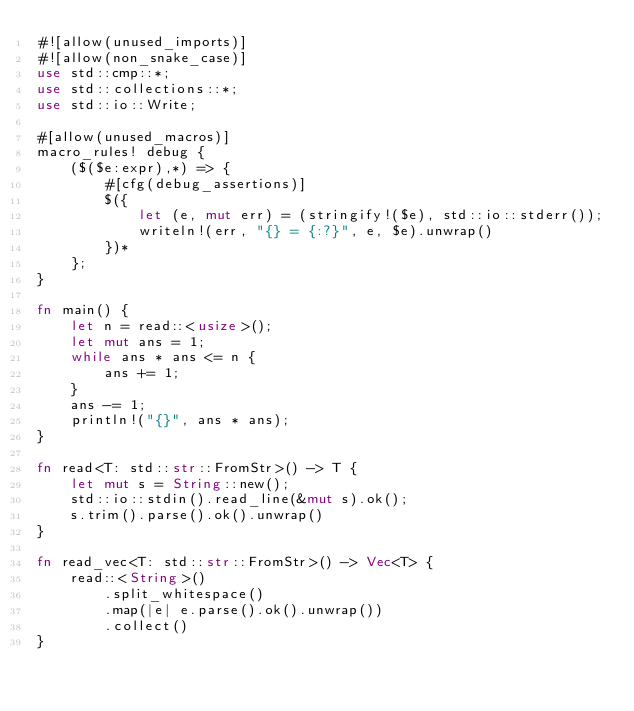Convert code to text. <code><loc_0><loc_0><loc_500><loc_500><_Rust_>#![allow(unused_imports)]
#![allow(non_snake_case)]
use std::cmp::*;
use std::collections::*;
use std::io::Write;

#[allow(unused_macros)]
macro_rules! debug {
    ($($e:expr),*) => {
        #[cfg(debug_assertions)]
        $({
            let (e, mut err) = (stringify!($e), std::io::stderr());
            writeln!(err, "{} = {:?}", e, $e).unwrap()
        })*
    };
}

fn main() {
    let n = read::<usize>();
    let mut ans = 1;
    while ans * ans <= n {
        ans += 1;
    }
    ans -= 1;
    println!("{}", ans * ans);
}

fn read<T: std::str::FromStr>() -> T {
    let mut s = String::new();
    std::io::stdin().read_line(&mut s).ok();
    s.trim().parse().ok().unwrap()
}

fn read_vec<T: std::str::FromStr>() -> Vec<T> {
    read::<String>()
        .split_whitespace()
        .map(|e| e.parse().ok().unwrap())
        .collect()
}
</code> 